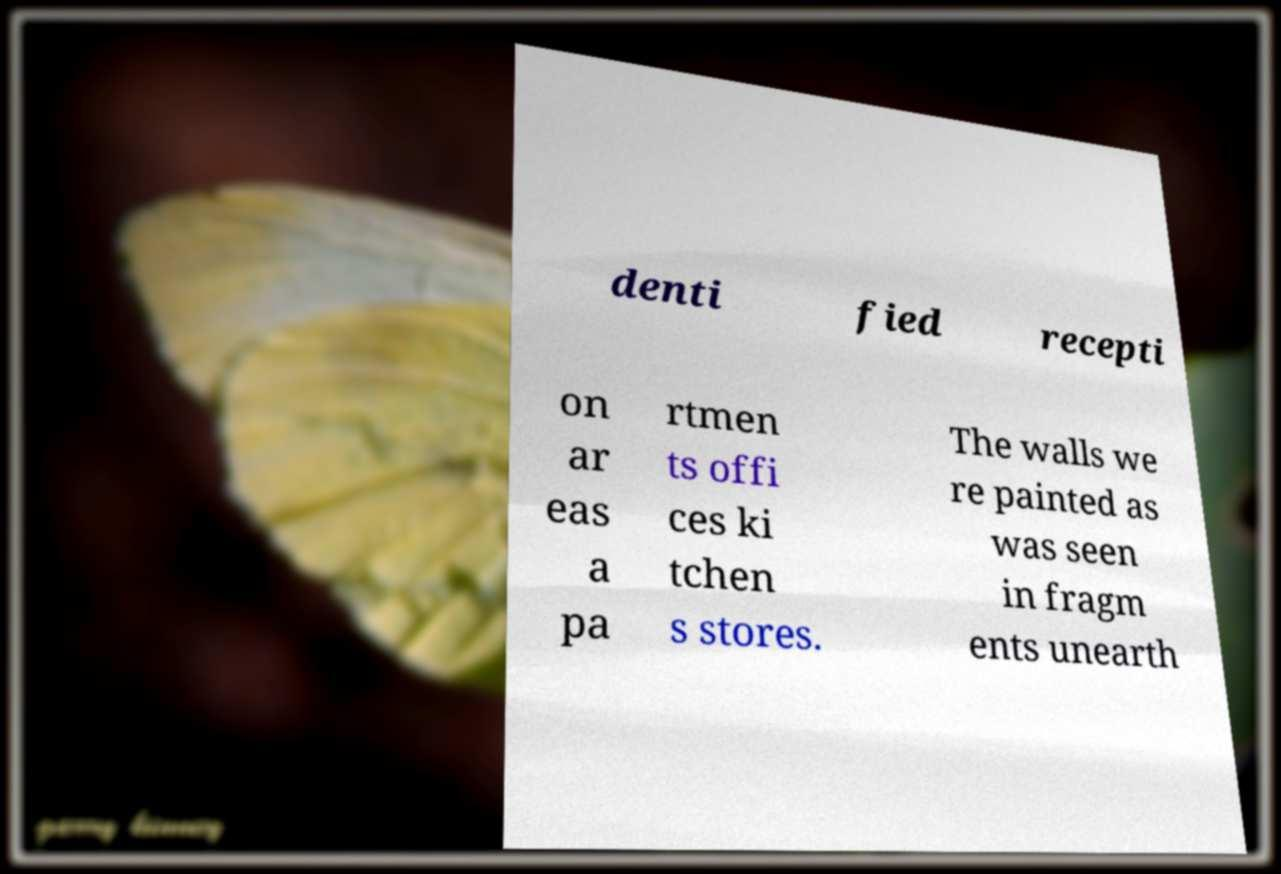Please read and relay the text visible in this image. What does it say? denti fied recepti on ar eas a pa rtmen ts offi ces ki tchen s stores. The walls we re painted as was seen in fragm ents unearth 